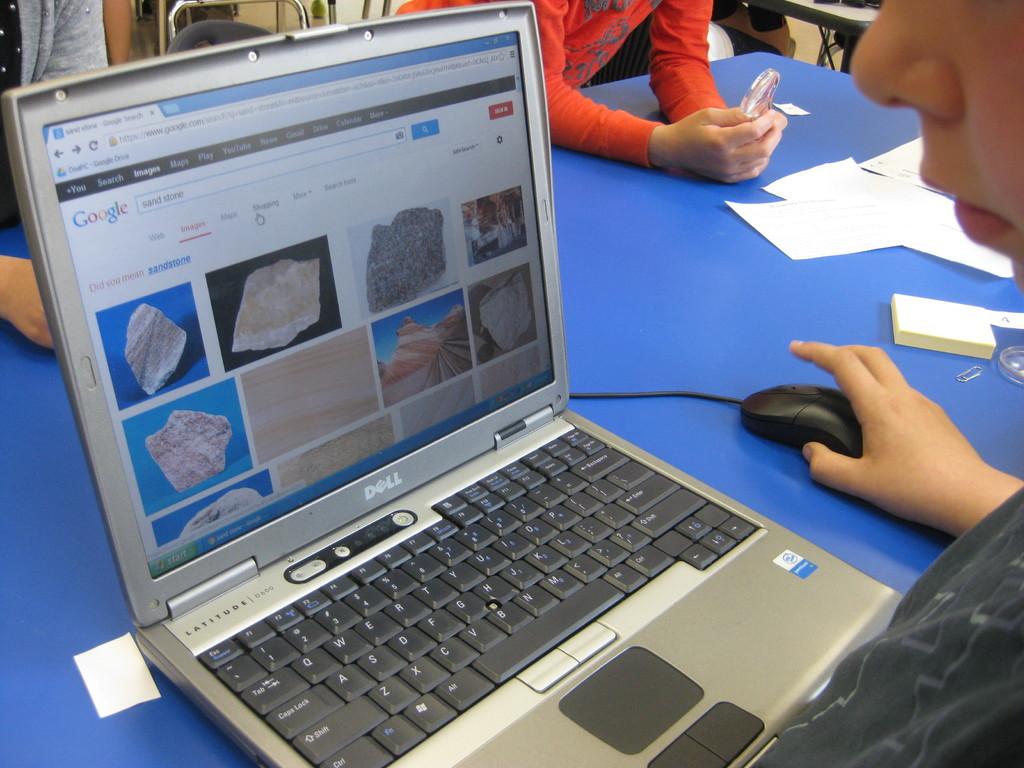What website is this person viewing?
Give a very brief answer. Google. What brand is the laptop?
Offer a terse response. Dell. 